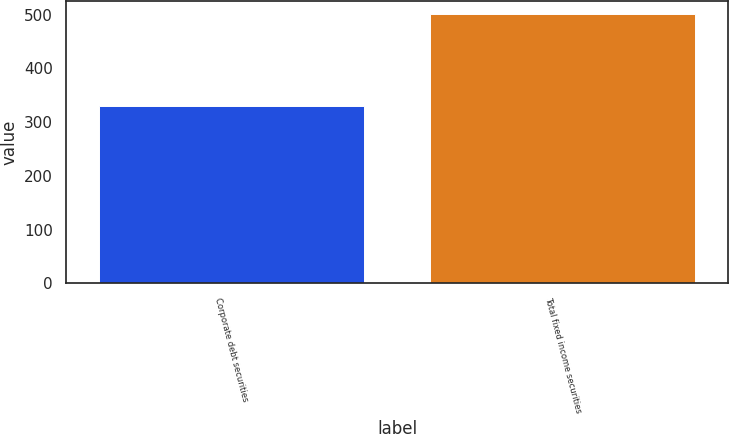Convert chart to OTSL. <chart><loc_0><loc_0><loc_500><loc_500><bar_chart><fcel>Corporate debt securities<fcel>Total fixed income securities<nl><fcel>330.7<fcel>500.8<nl></chart> 